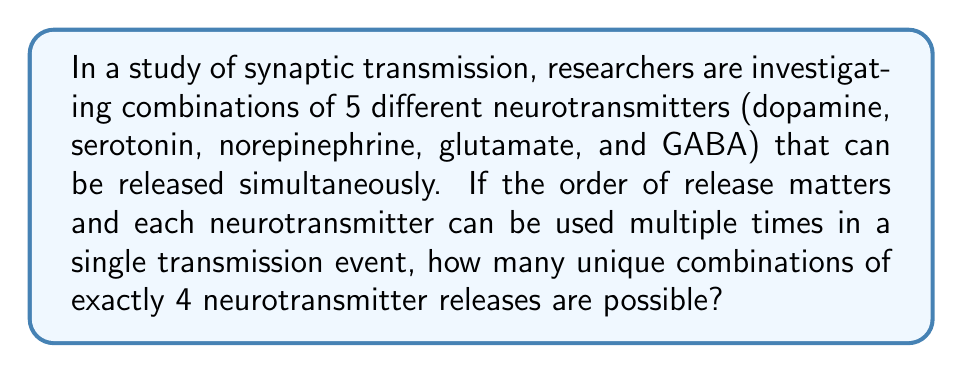Help me with this question. Let's approach this step-by-step:

1) This is a permutation problem with repetition allowed. The order matters (as specified in the question), and each neurotransmitter can be used multiple times.

2) We have 5 choices for each of the 4 positions in our permutation.

3) The formula for permutations with repetition is:

   $$ n^r $$

   Where $n$ is the number of types of items to choose from, and $r$ is the number of items being chosen.

4) In this case:
   $n = 5$ (5 types of neurotransmitters)
   $r = 4$ (4 neurotransmitters are released in each event)

5) Plugging these values into our formula:

   $$ 5^4 = 5 \times 5 \times 5 \times 5 = 625 $$

6) Therefore, there are 625 possible unique combinations of neurotransmitter releases.

This large number of combinations could explain the complexity of neural signaling and the diverse effects of altered states of consciousness on neurotransmitter systems.
Answer: 625 